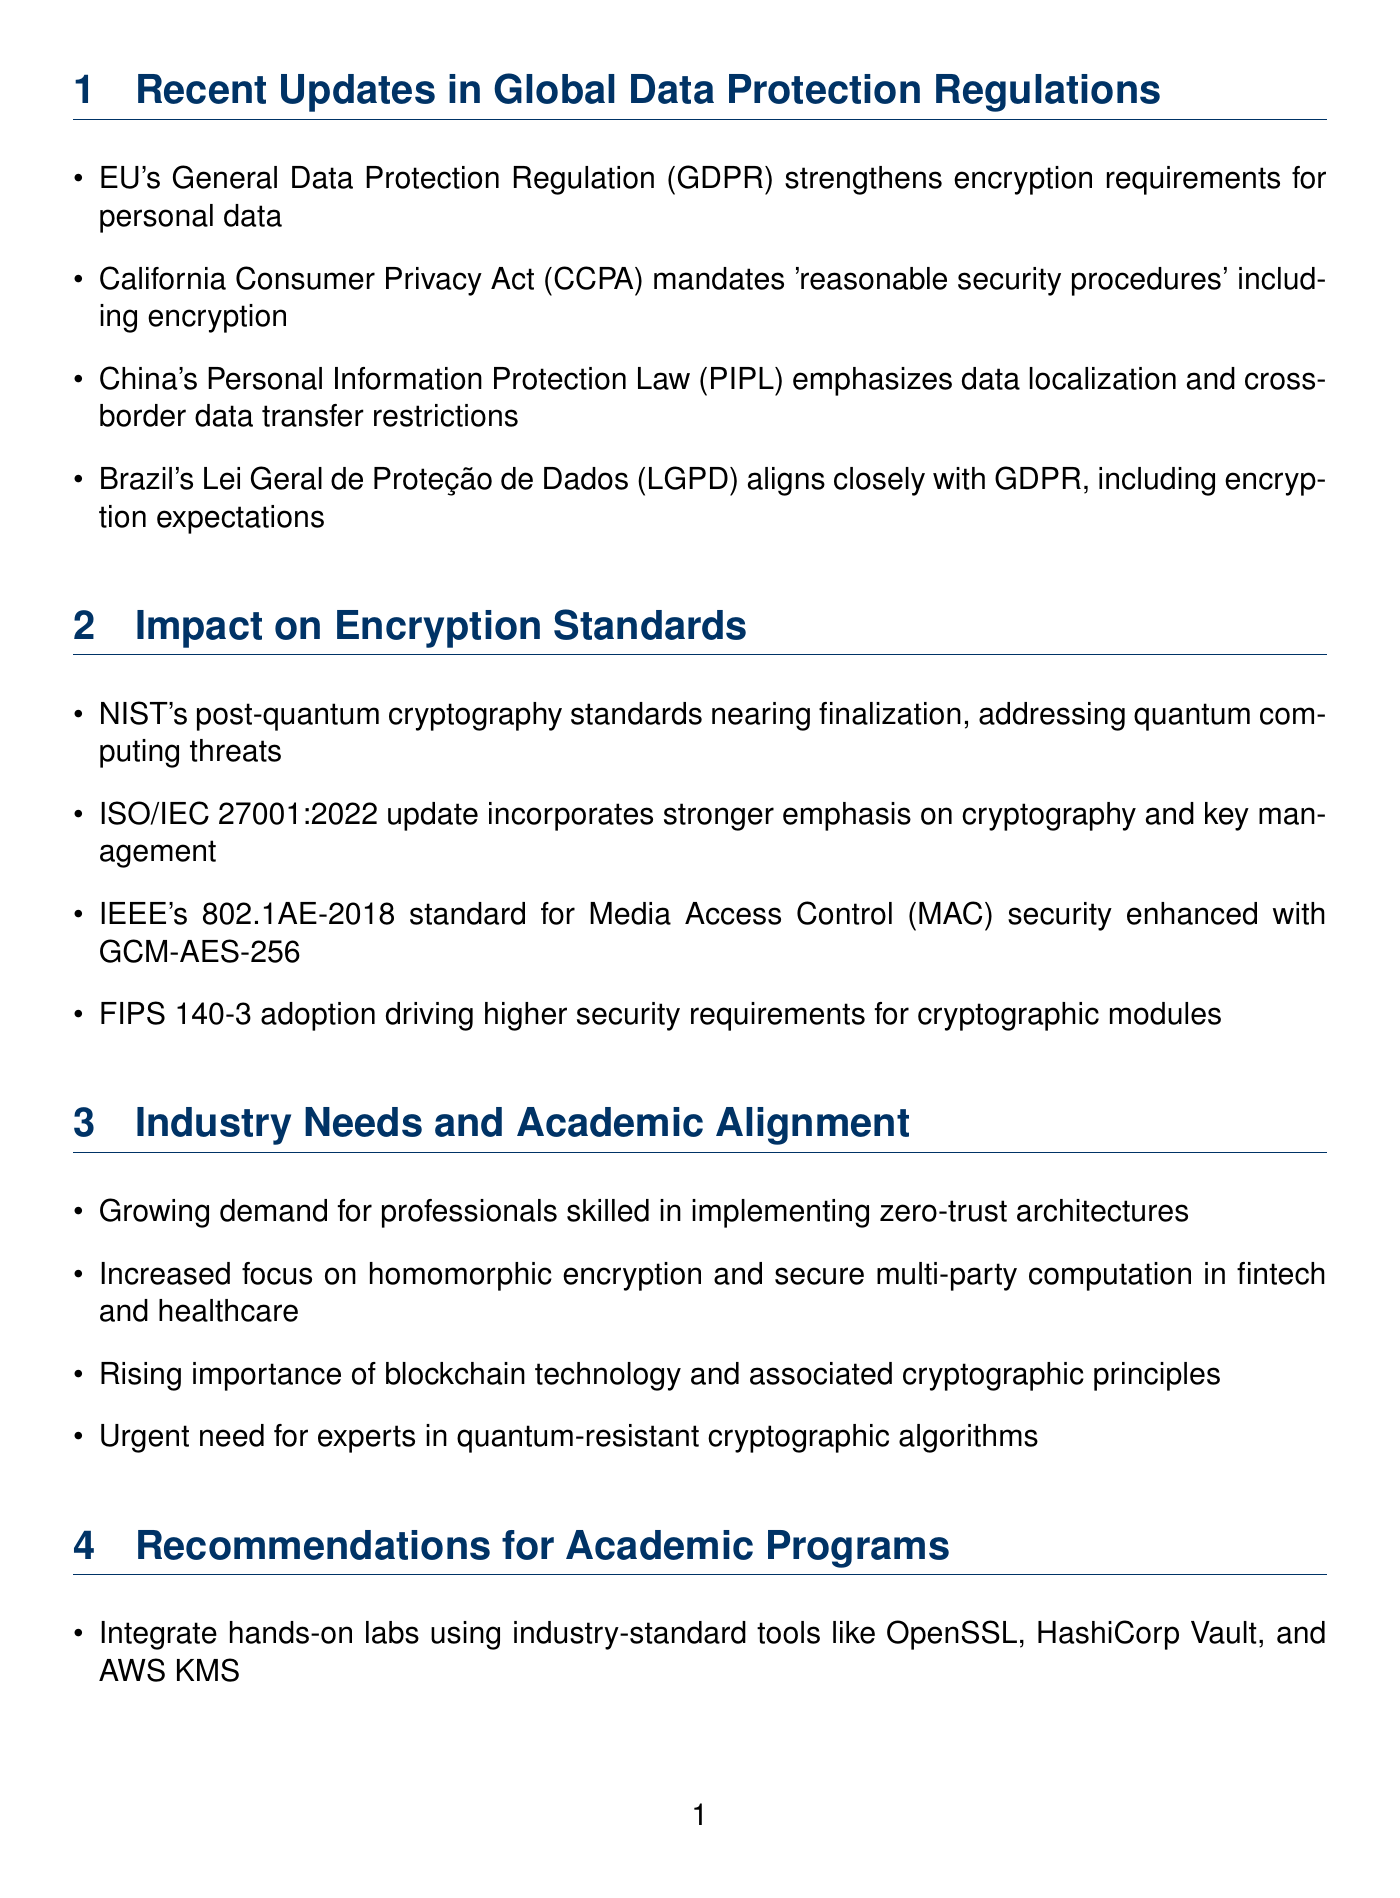What is the title of the newsletter? The title is presented at the top of the document, summarizing the focus of the newsletter.
Answer: Encryption in Focus: Global Data Protection and Academic Alignment Which regulation emphasizes data localization? The content specifies which global regulation includes this requirement, identified in the updates.
Answer: China's Personal Information Protection Law (PIPL) What is the new emphasis in ISO/IEC 27001:2022? The document mentions the focus areas in the update to this standard related to encryption.
Answer: Stronger emphasis on cryptography and key management Which cryptographic standard is nearing finalization? The newsletter discusses various standards and mentions one that specifically addresses a threat related to quantum computing.
Answer: NIST's post-quantum cryptography standards What is a growing industry demand mentioned in the document? The text highlights specific skills that are increasingly needed in the cybersecurity field.
Answer: Professionals skilled in implementing zero-trust architectures Which organization is recommended for research partnerships? The document lists several organizations for collaboration in research, providing details on their focus on standard development.
Answer: NIST When is the RSA Conference 2023? The newsletter lists events, and one of them is specifically identified by its name and content.
Answer: The exact date is not provided in the text What is the call to action in the newsletter? The document has a section identifying an action the readers are encouraged to take, including details on the event's theme and participants.
Answer: Join our upcoming webinar: 'Bridging the Gap: Aligning Cybersecurity Education with Industry Demands' 